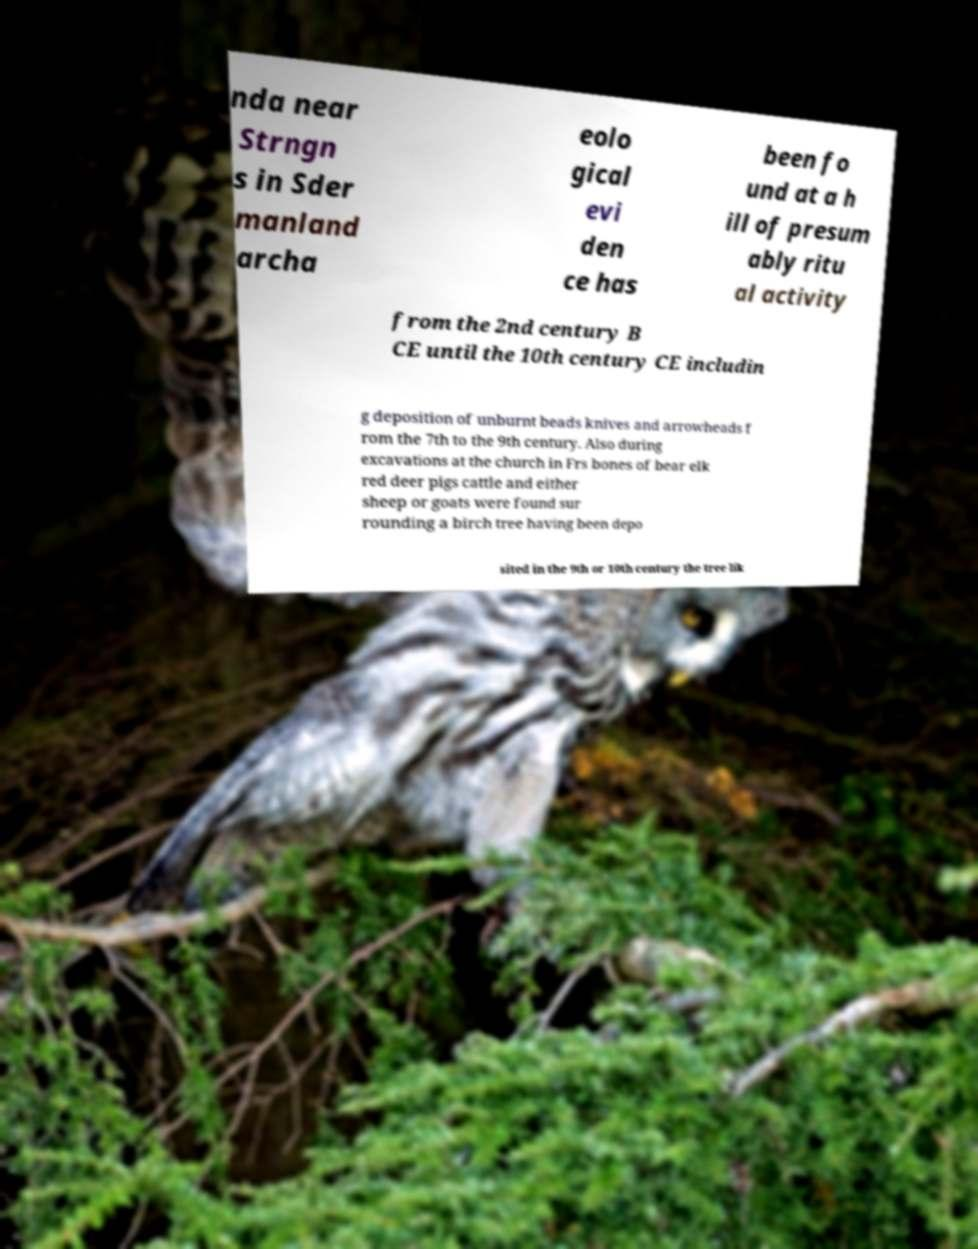Could you assist in decoding the text presented in this image and type it out clearly? nda near Strngn s in Sder manland archa eolo gical evi den ce has been fo und at a h ill of presum ably ritu al activity from the 2nd century B CE until the 10th century CE includin g deposition of unburnt beads knives and arrowheads f rom the 7th to the 9th century. Also during excavations at the church in Frs bones of bear elk red deer pigs cattle and either sheep or goats were found sur rounding a birch tree having been depo sited in the 9th or 10th century the tree lik 